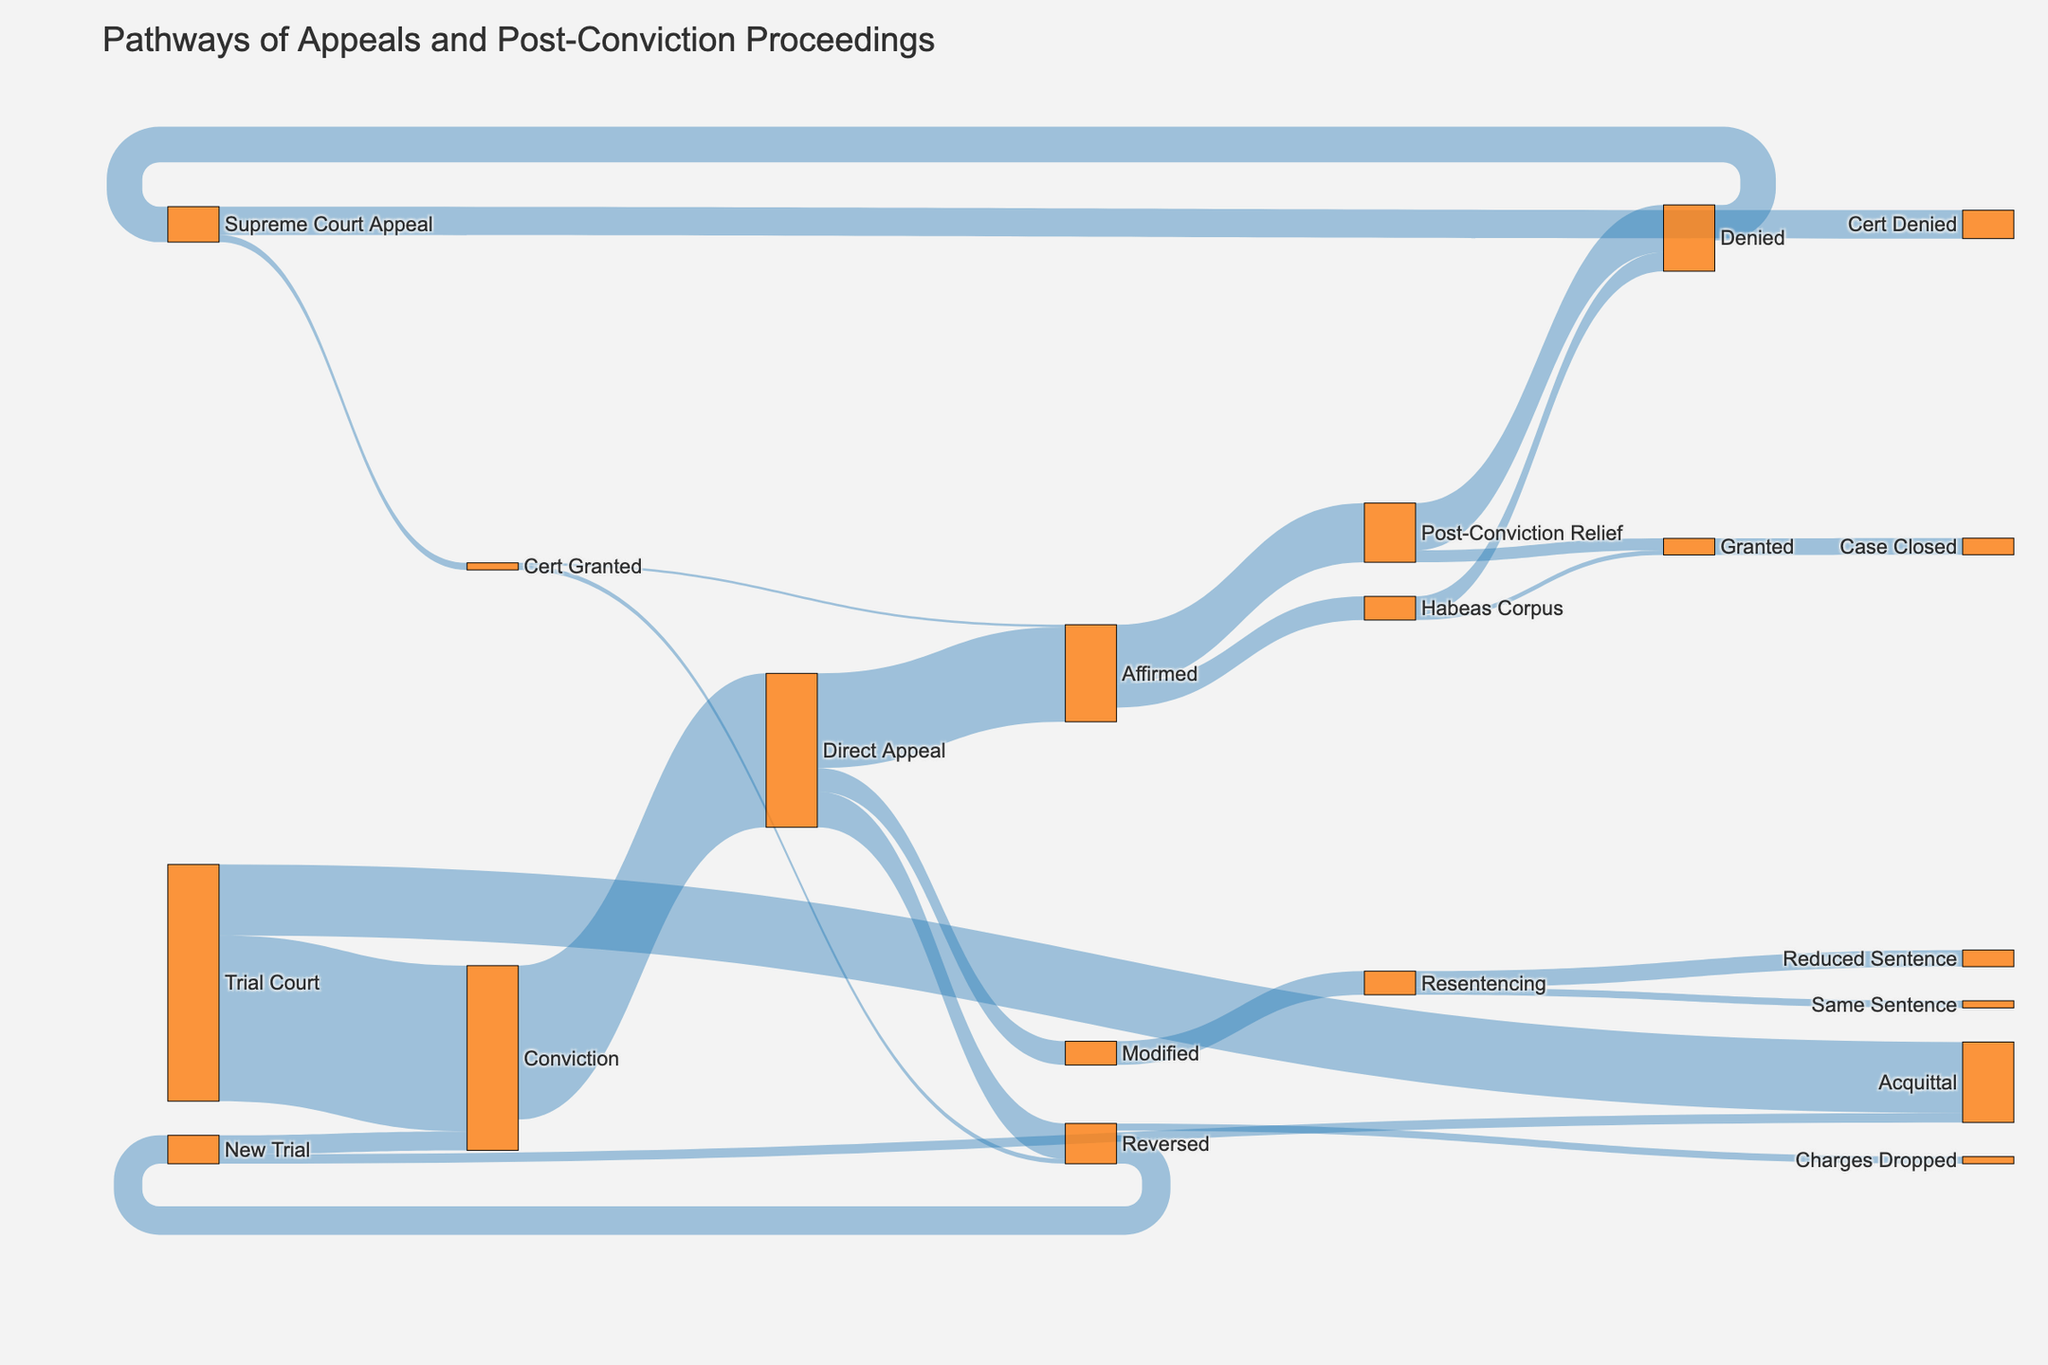what is the title of the figure? The title of the figure is located at the top and prominently displayed to summarize the content
Answer: Pathways of Appeals and Post-Conviction Proceedings how many pathways lead to an acquittal after the trial court process? There are two pathways to acquittal: directly from the trial court and after a new trial from a reversed direct appeal
Answer: 2 which appeal has the highest value and what is it? By looking at the thickness of the lines, it is evident which appeal pathway carries the highest volume. The Direct Appeal from Conviction has the highest value
Answer: Direct Appeal, 65 what is the combined total of affirmations following a direct appeal and an affirmed post-conviction relief? First, identify the affirmed values: 40 from Direct Appeal, and summing up the values of each affirmed outcome from post-conviction relief (20 + 10)
Answer: 70 after a conviction in the trial court, what percentage of cases proceed to direct appeal? Calculate the percentage of convictions that proceed to direct appeal out of the total convictions (direct appeal 65 out of 70)
Answer: 92.86% how many pathways directly lead to the supreme court appeal? There is one direct pathway leading to a Supreme Court Appeal from post-conviction relief denials
Answer: 1 how many total cases result in some form of granted relief after a post-conviction process? Adding the values from Post-Conviction Relief granted and Habeas Corpus granted
Answer: 7 are there more reversals or modifications following a direct appeal, and by how much? Compare the values of reversed and modified outcomes from Direct Appeal: reversed (15) and modified (10)
Answer: Reversals, 5 which pathway results in the same sentence being resentenced and what is its value? Trace the path from Modified to Resentencing and then to Same Sentence to find this data
Answer: Resentencing, 3 what is the number of cases for each type of outcome if denied post-conviction relief leads to supreme court appeal? After denial, the paths split into Cert Denied and Cert Granted. Summing up: Cert Denied (12) and Cert Granted (3)
Answer: 15 